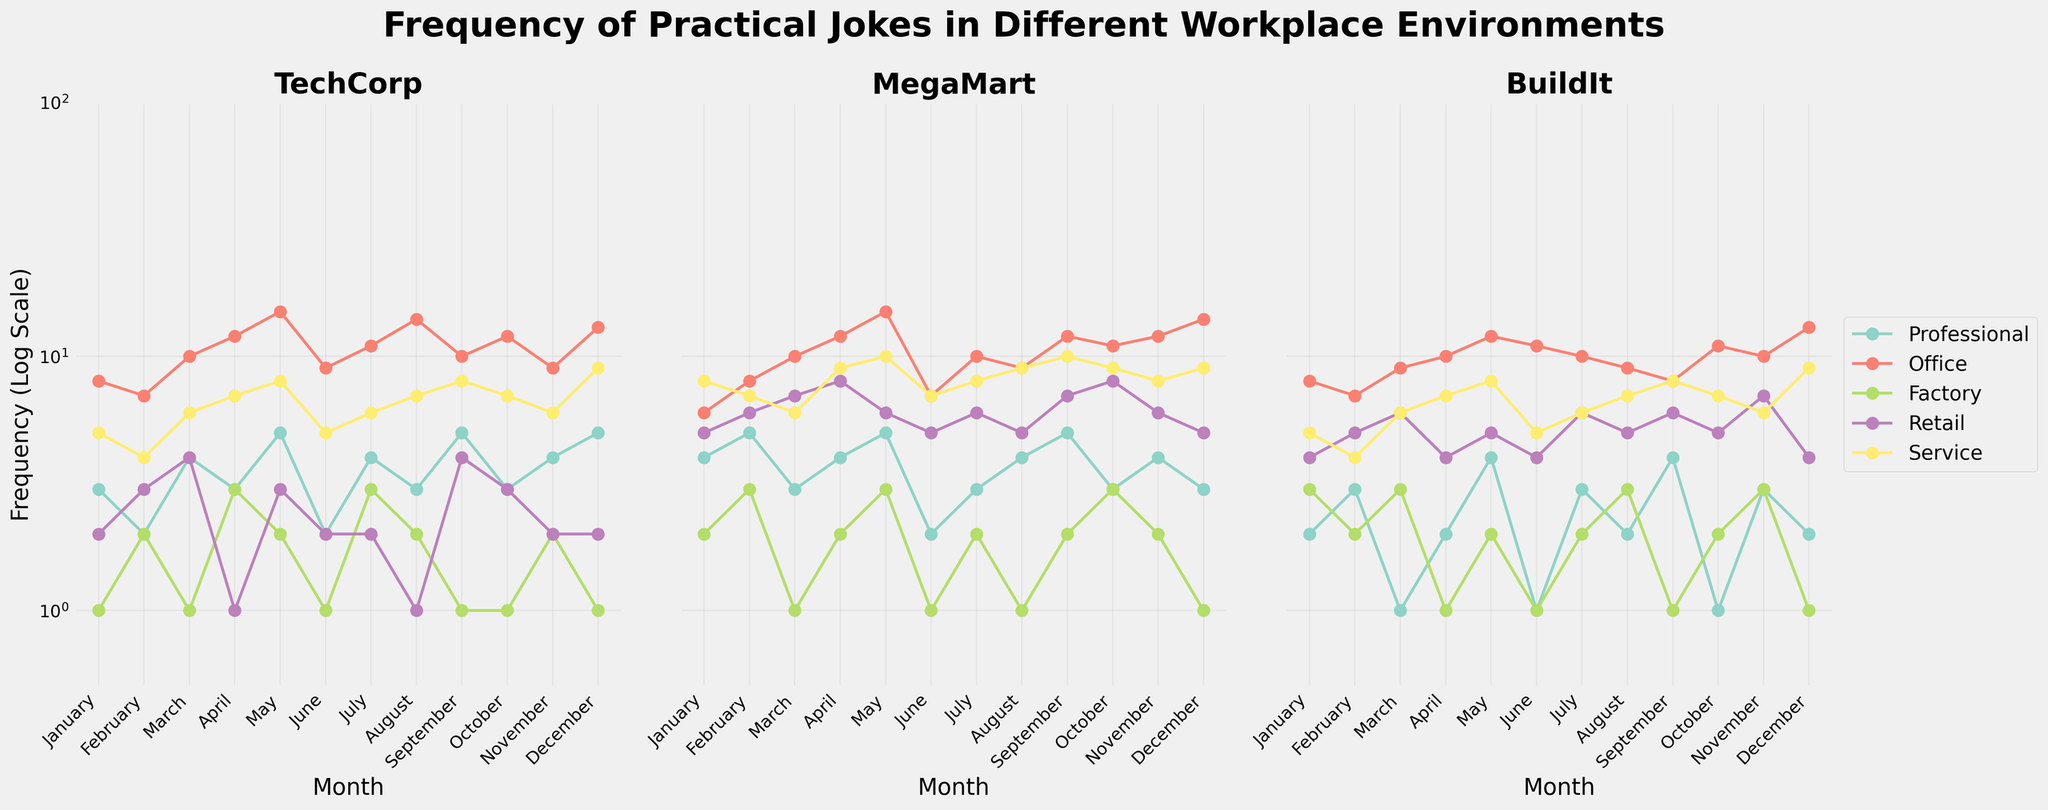What is the title of the figure? The title is usually placed at the top of the figure, written in a larger and bolder font. Look at the center-top of the figure.
Answer: Frequency of Practical Jokes in Different Workplace Environments How many workplace environments are analyzed in the figure? The legend in the figure lists all the environments analyzed. Count them.
Answer: 5 Which workplace environment has the highest average frequency of practical jokes at BuildIt? To find the highest average, sum up the frequencies for each environment at BuildIt and divide by 12 (number of months). Compare the averages.
Answer: Office In which month did TechCorp have the highest number of practical jokes in the Office environment? Examine the line representing the Office environment for TechCorp and look for the peak value, then check the corresponding month on the x-axis.
Answer: May Which company shows the most variability in the frequency of practical jokes in the Factory environment? To assess variability, look at the fluctuation of the Factory lines for each company. The greater the changes, the higher the variability.
Answer: MegaMart What is the y-axis label given for each subplot? The y-axis label helps to understand the measurement unit. Look at the left side of each subplot.
Answer: Frequency (Log Scale) What is the minimum frequency value for practical jokes in the Service environment across all companies? Identify the smallest data point for the Service lines across all subplots. On a log scale, the lowest possible value would be highlighted near the bottom.
Answer: 4 in BuildIt February How does the frequency of practical jokes in the Professional environment differ between TechCorp and MegaMart in December? Compare the December data points for the Professional environment lines in the TechCorp and MegaMart subplots.
Answer: TechCorp has 5, MegaMart has 3 Which workplace environment consistently shows the lowest frequency of practical jokes across all companies? Look for the environment that has the lowest trend line in all three subplots. Identify the one staying close to the bottom consistently.
Answer: Factory If you sum the frequency of practical jokes in the Retail environment for September across all companies, what is the total? Find the September values for the Retail environment in each subplot and sum them up.
Answer: 17 (4 + 7 + 6) 